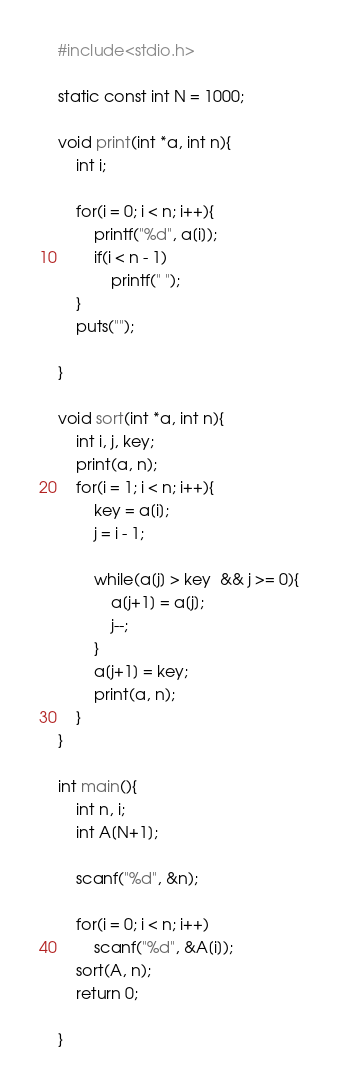<code> <loc_0><loc_0><loc_500><loc_500><_C_>#include<stdio.h>

static const int N = 1000;

void print(int *a, int n){
	int i;

	for(i = 0; i < n; i++){
		printf("%d", a[i]);
		if(i < n - 1)
			printf(" ");
	}
	puts("");

}

void sort(int *a, int n){
	int i, j, key;
	print(a, n);
	for(i = 1; i < n; i++){
		key = a[i];
		j = i - 1;

		while(a[j] > key  && j >= 0){
			a[j+1] = a[j];
			j--;
		}
		a[j+1] = key;
		print(a, n);
	}
}

int main(){
	int n, i;
	int A[N+1];

	scanf("%d", &n);

	for(i = 0; i < n; i++)
		scanf("%d", &A[i]);
	sort(A, n);
	return 0;

}</code> 